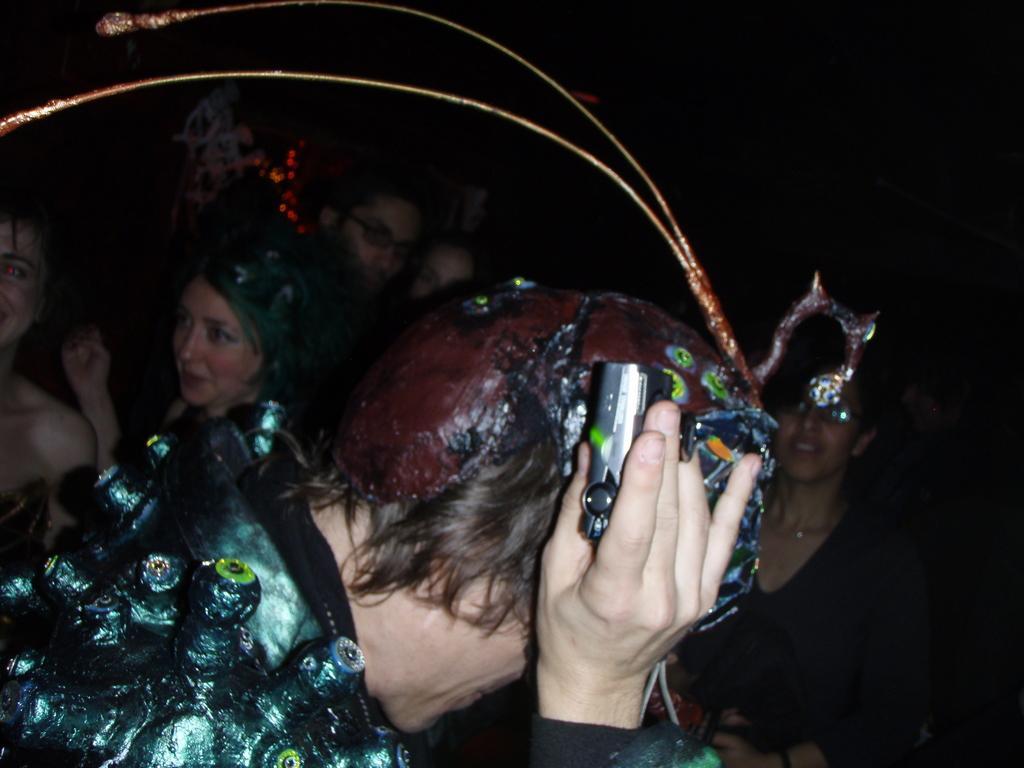In one or two sentences, can you explain what this image depicts? In this picture we can observe some people standing. We can observe a person here, holding camera in their hand. In the background it is completely dark. 